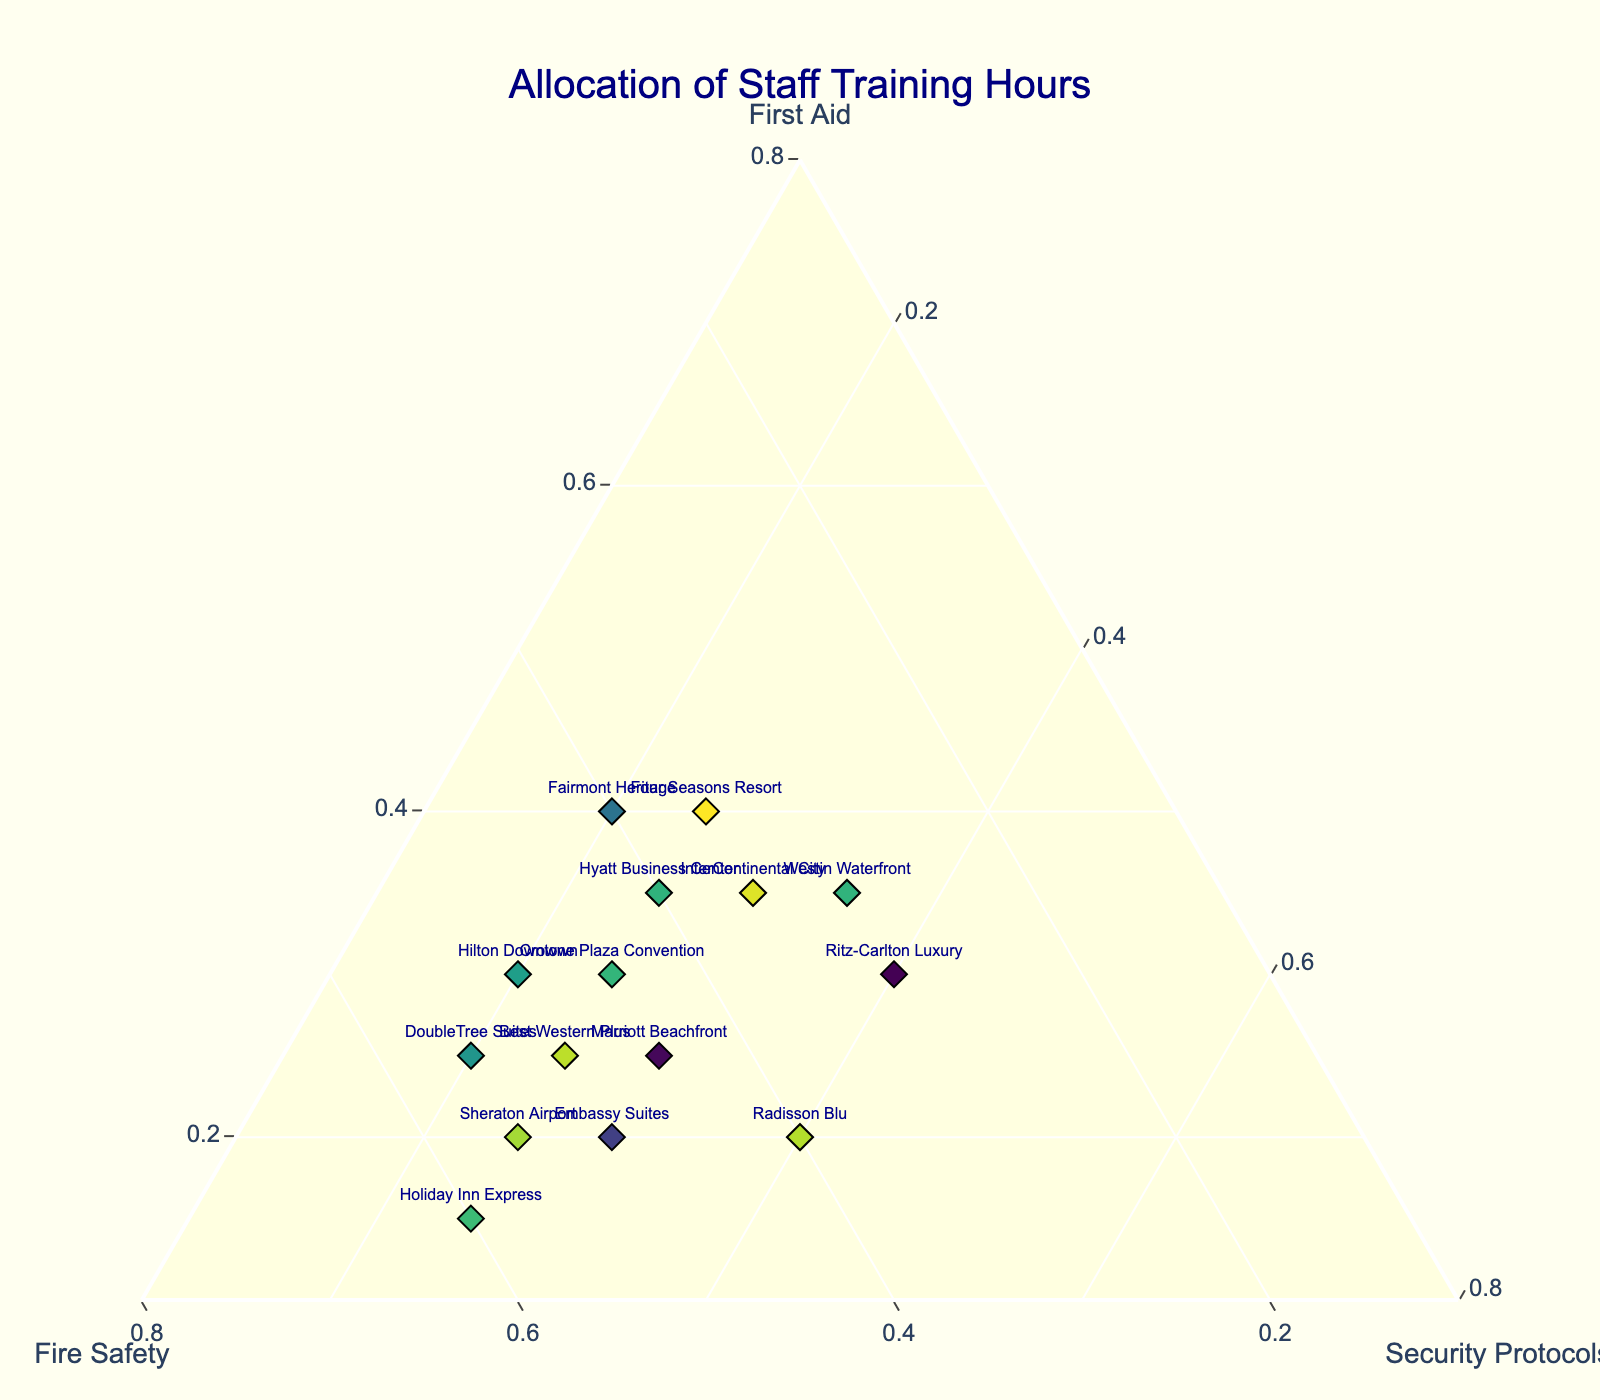How many hotels are shown in the plot? Count the number of distinct data points (markers) representing hotels in the plot. This can be determined by counting the labels or markers.
Answer: 15 Which hotel has the highest allocation for fire safety? Look for the marker positioned closest to the fire safety corner of the ternary plot (top vertex), which should have the smallest distance to this axis.
Answer: Holiday Inn Express Which two hotels have the same allocation for first aid but differ in fire safety and security protocols? Find and compare data points with the same position on the first aid axis and analyze their positions relative to the fire safety and security protocols axes.
Answer: InterContinental City and Fairmont Heritage What is the average allocation for security protocols across all hotels? To find this, add up all the security protocol percentages for each hotel, then divide the sum by the number of hotels (15). (20 + 30 + 25 + 25 + 25 + 25 + 40 + 25 + 30 + 40 + 25 + 20 + 35 + 20 + 30) / 15 = 365 / 15 = 24.3
Answer: 24.3% Between Marriott Beachfront and Ritz-Carlton Luxury, which hotel has a higher percentage allocated to security protocols? Compare the security protocols percentages for Marriott Beachfront (30%) and Ritz-Carlton Luxury (40%).
Answer: Ritz-Carlton Luxury Which hotel dedicates equal time to fire safety and security protocols but different time to first aid? Look for a hotel with equal values on both fire safety and security protocols' axes while differing on the first aid axis.
Answer: Radisson Blu How does the first aid training allocation for Four Seasons Resort compare with Hyatt Business Center? Compare the first aid percentages for Four Seasons Resort (40%) with Hyatt Business Center (35%).
Answer: Four Seasons Resort has a higher percentage Which hotel has the maximum difference in hours allocated between first aid and fire safety? Calculate the absolute difference between first aid and fire safety hours for each hotel and identify the largest difference.
Answer: Holiday Inn Express (difference of 45%) What is the composition trend of hotels allocating more to fire safety than security protocols? Examine the general trend by identifying hotels where the value for fire safety is greater than that for security protocols and analyze their positions. Many hotels prioritize fire safety over security protocols.
Answer: Fire safety > Security protocols trend seen in majority Identify the hotel with balanced allocation among first aid, fire safety, and security protocols. Look for a data point approximately equidistant from all three axes, indicating roughly equal allocation.
Answer: Ritz-Carlton Luxury 